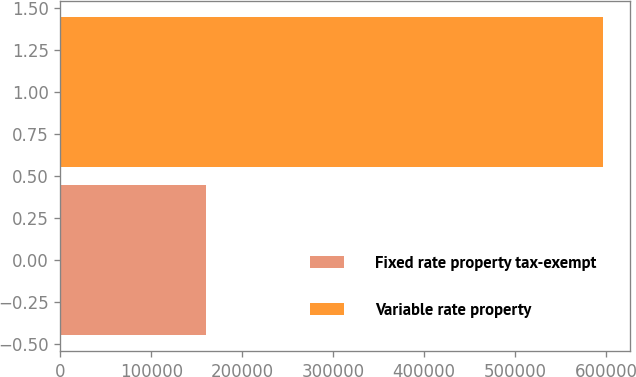<chart> <loc_0><loc_0><loc_500><loc_500><bar_chart><fcel>Fixed rate property tax-exempt<fcel>Variable rate property<nl><fcel>159893<fcel>596549<nl></chart> 